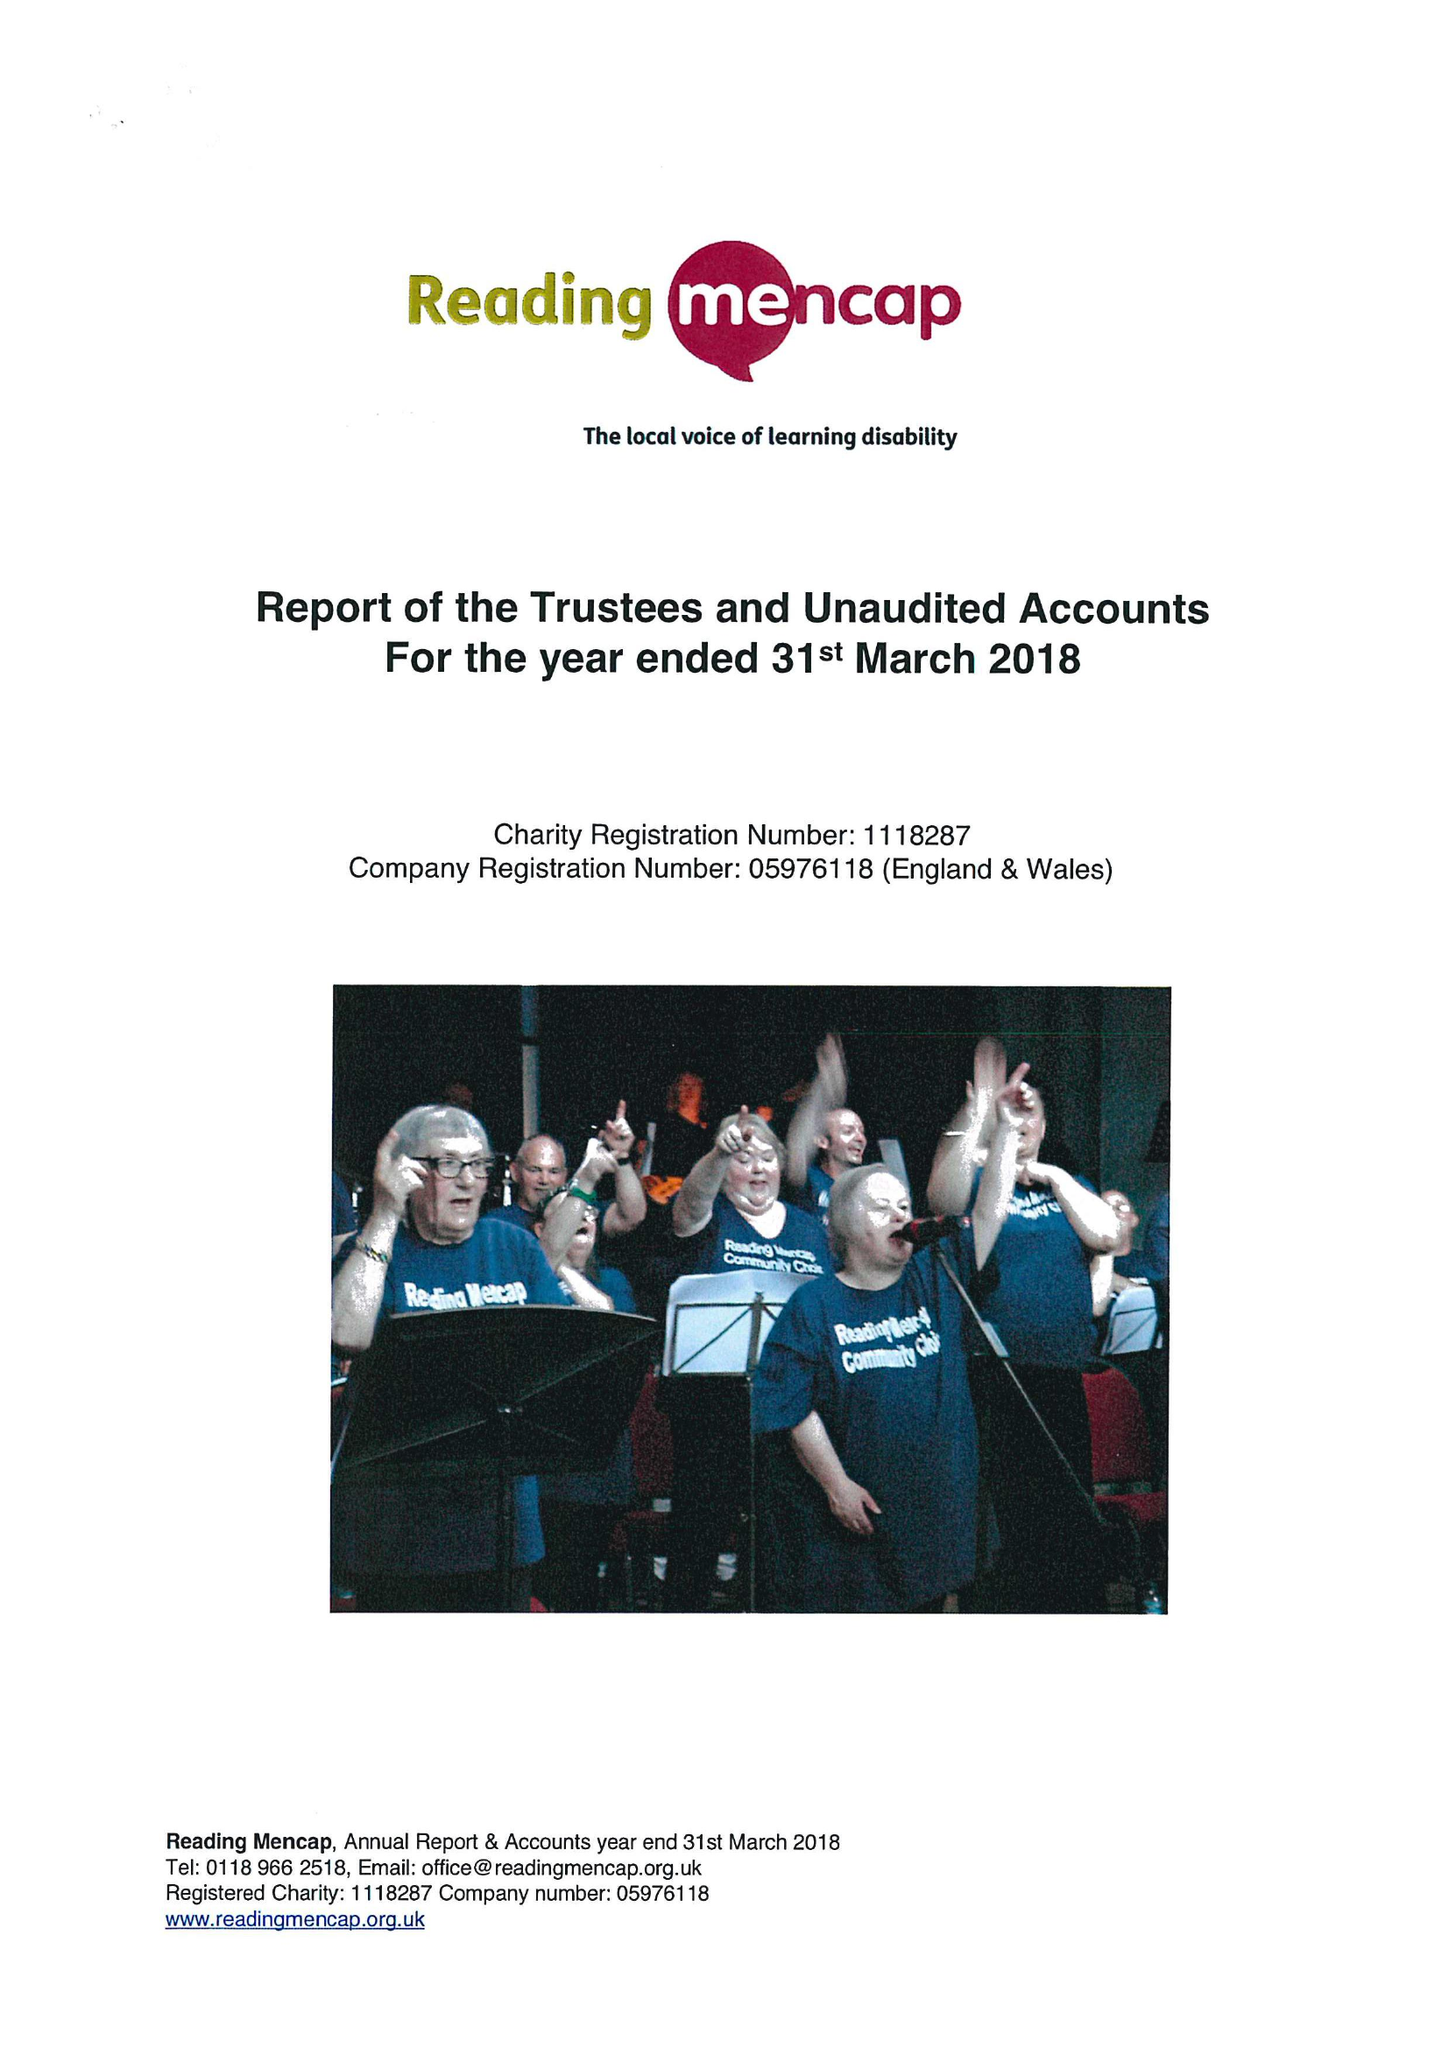What is the value for the charity_number?
Answer the question using a single word or phrase. 1118287 